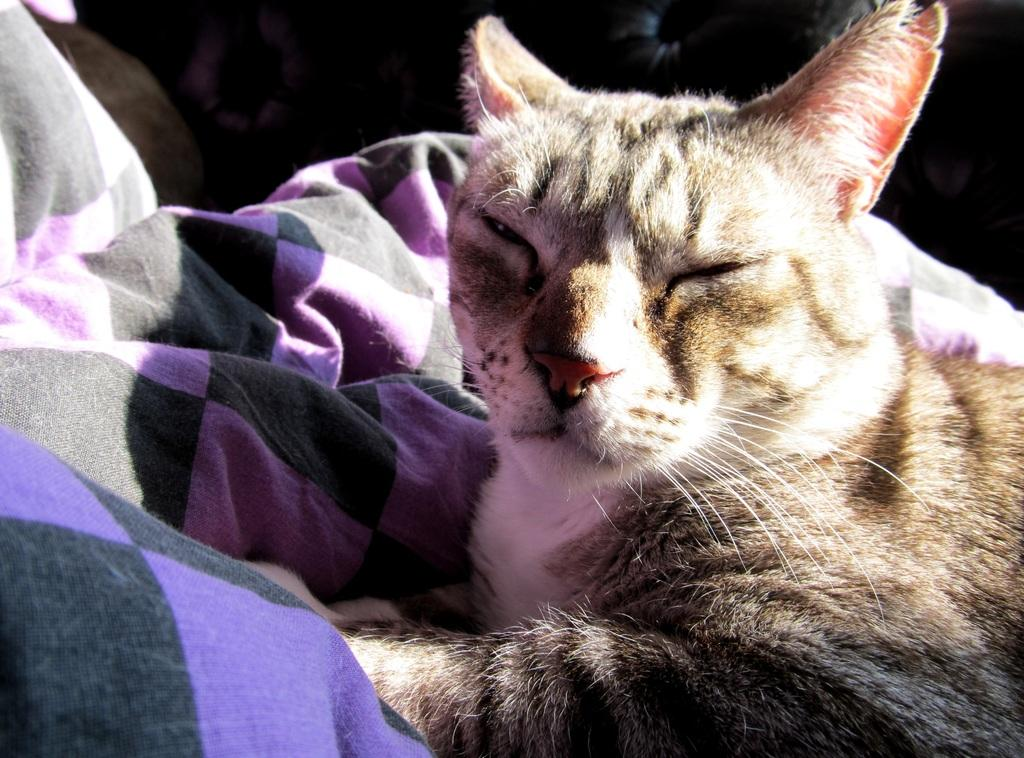What type of parent-teacher class is the woman teaching in the image? There is no image or woman present, so it is not possible to answer that question. 